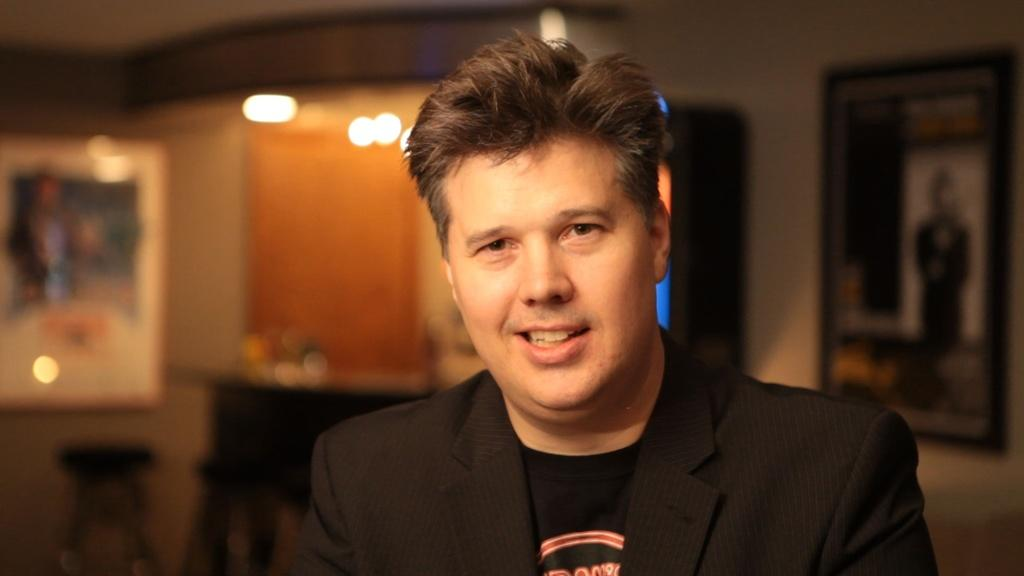Who or what is present in the image? There is a person in the image. What is the person wearing? The person is wearing a black coat. What can be seen in the background of the image? There is a photo frame and lights visible in the background of the image. What type of ship can be seen sailing in the background of the image? There is no ship present in the image; it only features a person wearing a black coat, a photo frame, and lights in the background. 